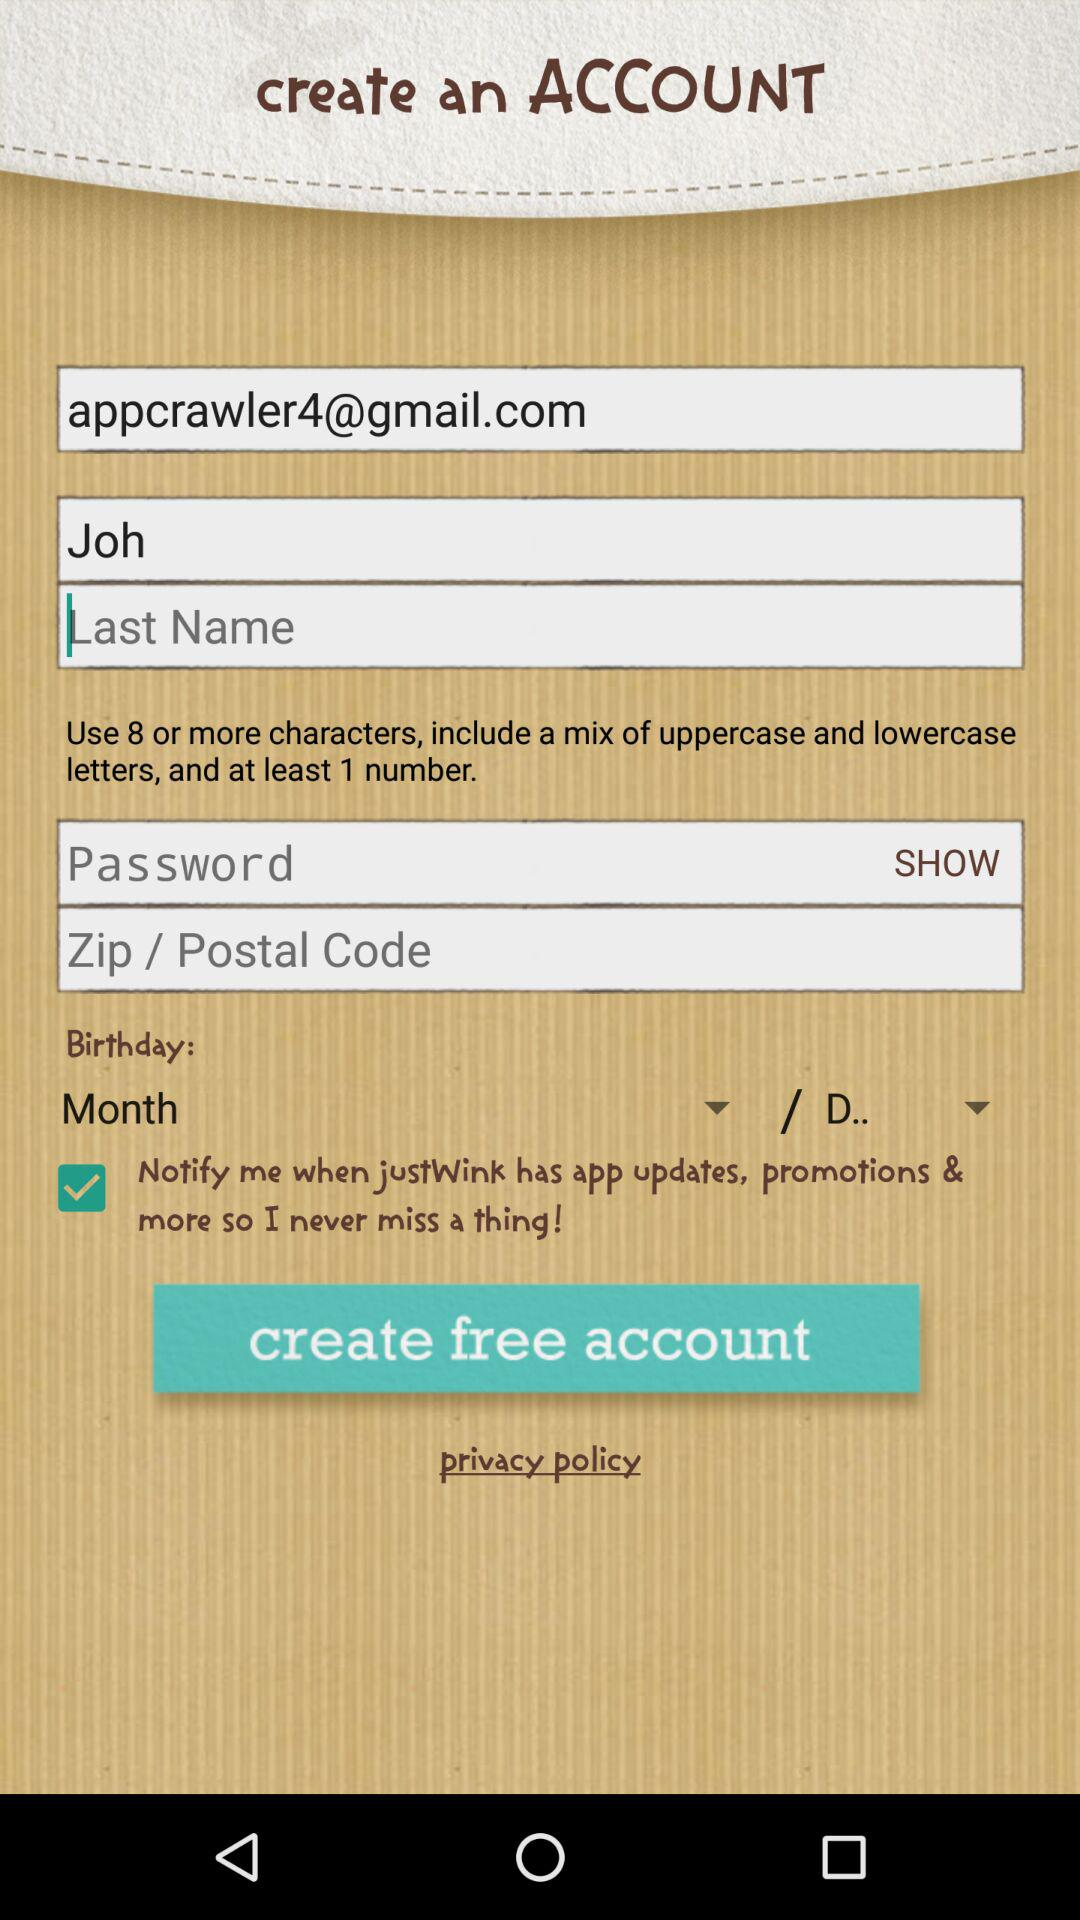What are the minimum required characters in a password? The minimum number of characters required in a password is 8. 